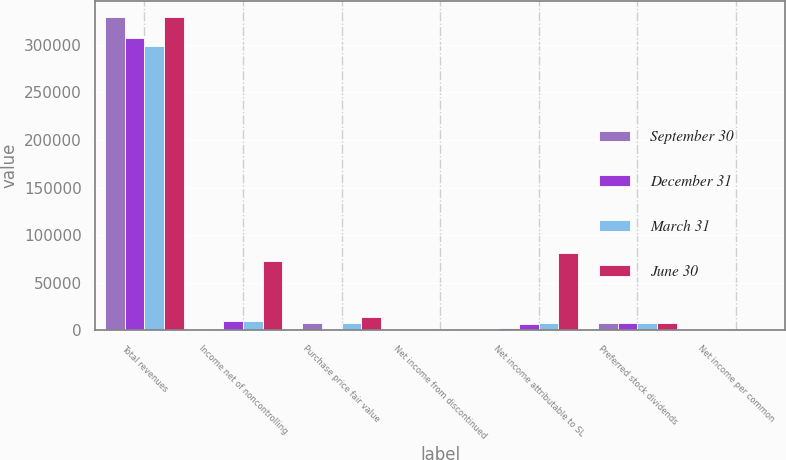<chart> <loc_0><loc_0><loc_500><loc_500><stacked_bar_chart><ecel><fcel>Total revenues<fcel>Income net of noncontrolling<fcel>Purchase price fair value<fcel>Net income from discontinued<fcel>Net income attributable to SL<fcel>Preferred stock dividends<fcel>Net income per common<nl><fcel>September 30<fcel>328877<fcel>1833<fcel>8306<fcel>1116<fcel>2808<fcel>7543<fcel>0.03<nl><fcel>December 31<fcel>306624<fcel>9544<fcel>999<fcel>1116<fcel>7079<fcel>7545<fcel>0.08<nl><fcel>March 31<fcel>298705<fcel>10176<fcel>7545<fcel>1675<fcel>7545<fcel>7545<fcel>6.3<nl><fcel>June 30<fcel>329222<fcel>72898<fcel>13788<fcel>1873<fcel>80887<fcel>7545<fcel>1.02<nl></chart> 